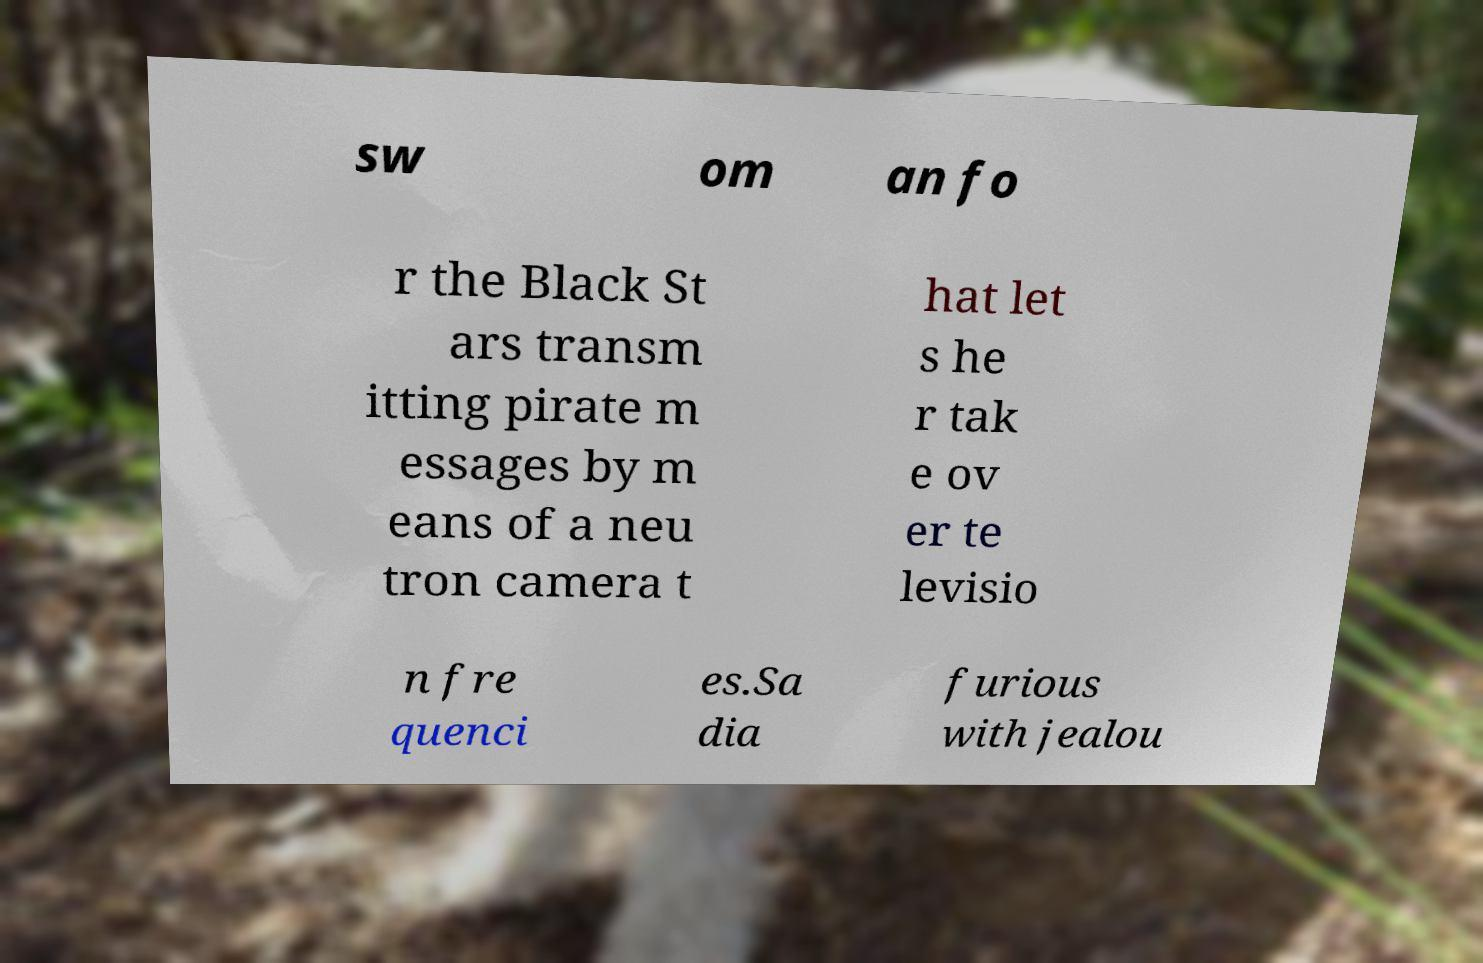Can you read and provide the text displayed in the image?This photo seems to have some interesting text. Can you extract and type it out for me? sw om an fo r the Black St ars transm itting pirate m essages by m eans of a neu tron camera t hat let s he r tak e ov er te levisio n fre quenci es.Sa dia furious with jealou 